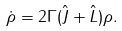Convert formula to latex. <formula><loc_0><loc_0><loc_500><loc_500>\dot { \rho } = 2 \Gamma ( \hat { J } + \hat { L } ) \rho .</formula> 